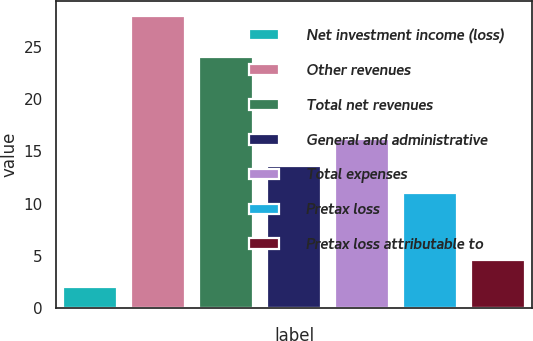Convert chart to OTSL. <chart><loc_0><loc_0><loc_500><loc_500><bar_chart><fcel>Net investment income (loss)<fcel>Other revenues<fcel>Total net revenues<fcel>General and administrative<fcel>Total expenses<fcel>Pretax loss<fcel>Pretax loss attributable to<nl><fcel>2<fcel>28<fcel>24<fcel>13.6<fcel>16.2<fcel>11<fcel>4.6<nl></chart> 